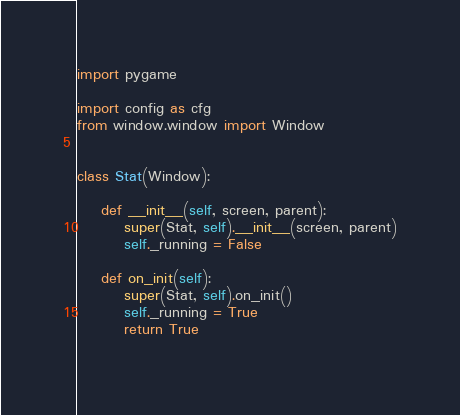Convert code to text. <code><loc_0><loc_0><loc_500><loc_500><_Python_>import pygame

import config as cfg
from window.window import Window

 
class Stat(Window):

    def __init__(self, screen, parent):
        super(Stat, self).__init__(screen, parent)
        self._running = False

    def on_init(self):
        super(Stat, self).on_init()
        self._running = True
        return True
    </code> 